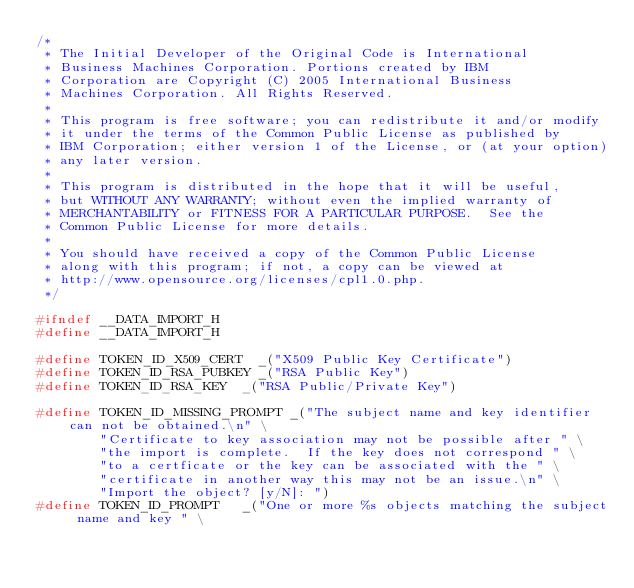<code> <loc_0><loc_0><loc_500><loc_500><_C_>/*
 * The Initial Developer of the Original Code is International
 * Business Machines Corporation. Portions created by IBM
 * Corporation are Copyright (C) 2005 International Business
 * Machines Corporation. All Rights Reserved.
 *
 * This program is free software; you can redistribute it and/or modify
 * it under the terms of the Common Public License as published by
 * IBM Corporation; either version 1 of the License, or (at your option)
 * any later version.
 *
 * This program is distributed in the hope that it will be useful,
 * but WITHOUT ANY WARRANTY; without even the implied warranty of
 * MERCHANTABILITY or FITNESS FOR A PARTICULAR PURPOSE.  See the
 * Common Public License for more details.
 *
 * You should have received a copy of the Common Public License
 * along with this program; if not, a copy can be viewed at
 * http://www.opensource.org/licenses/cpl1.0.php.
 */

#ifndef __DATA_IMPORT_H
#define __DATA_IMPORT_H

#define TOKEN_ID_X509_CERT	_("X509 Public Key Certificate")
#define TOKEN_ID_RSA_PUBKEY	_("RSA Public Key")
#define TOKEN_ID_RSA_KEY	_("RSA Public/Private Key")

#define TOKEN_ID_MISSING_PROMPT	_("The subject name and key identifier can not be obtained.\n" \
				"Certificate to key association may not be possible after " \
				"the import is complete.  If the key does not correspond " \
				"to a certficate or the key can be associated with the " \
				"certificate in another way this may not be an issue.\n" \
				"Import the object? [y/N]: ")
#define TOKEN_ID_PROMPT		_("One or more %s objects matching the subject name and key " \</code> 